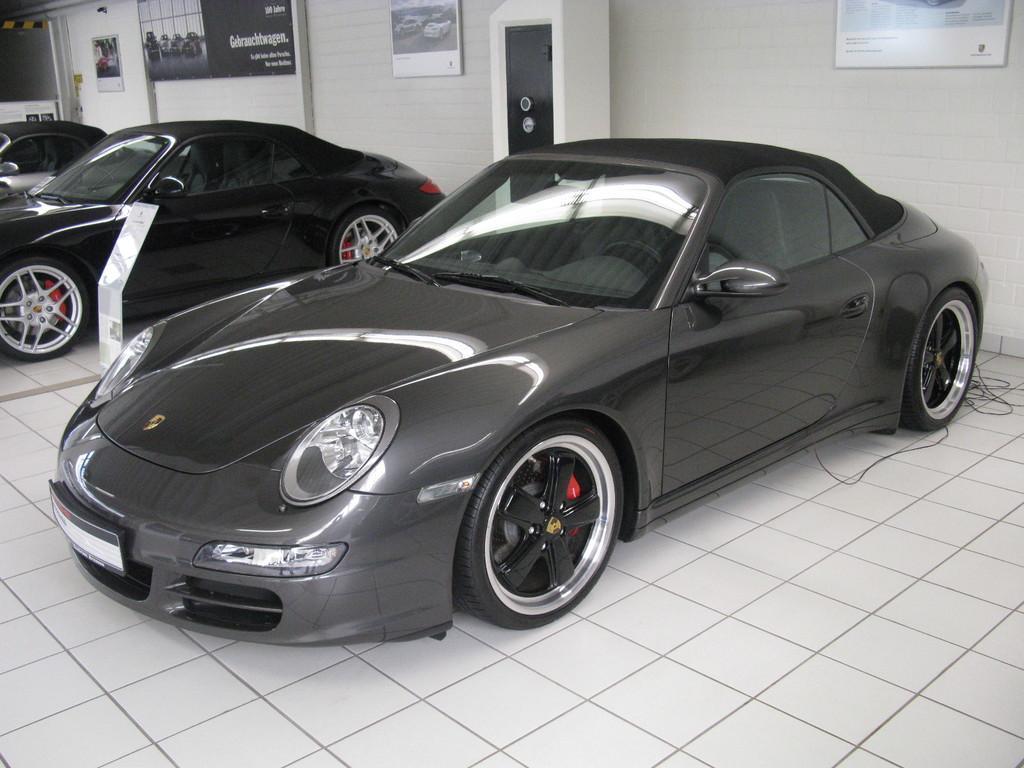Can you describe this image briefly? In this image there are boards, vehicles, locker, vehicles, tile floor and objects. Something is written on the boards. Boards are on the wall. 